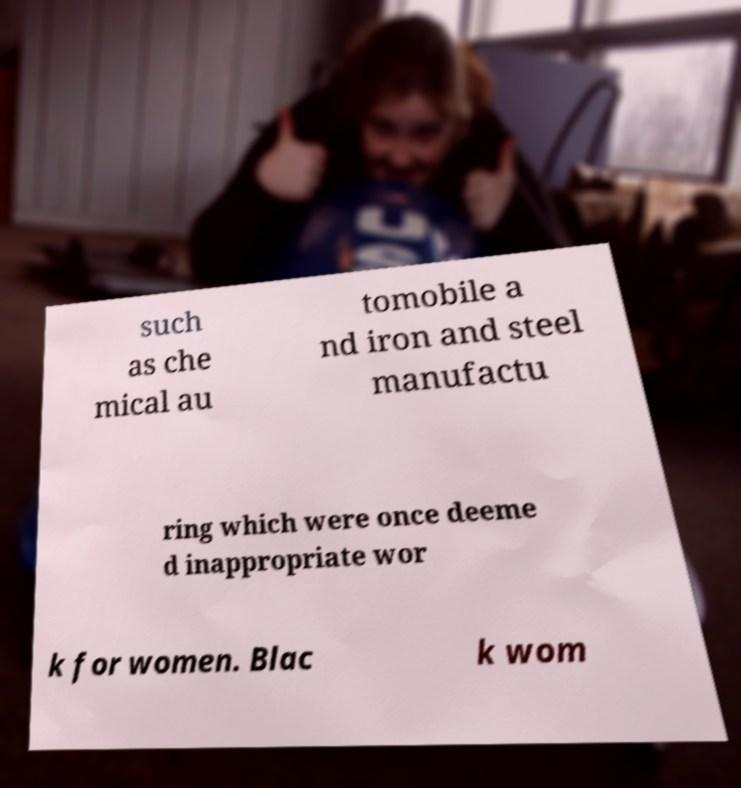Could you extract and type out the text from this image? such as che mical au tomobile a nd iron and steel manufactu ring which were once deeme d inappropriate wor k for women. Blac k wom 